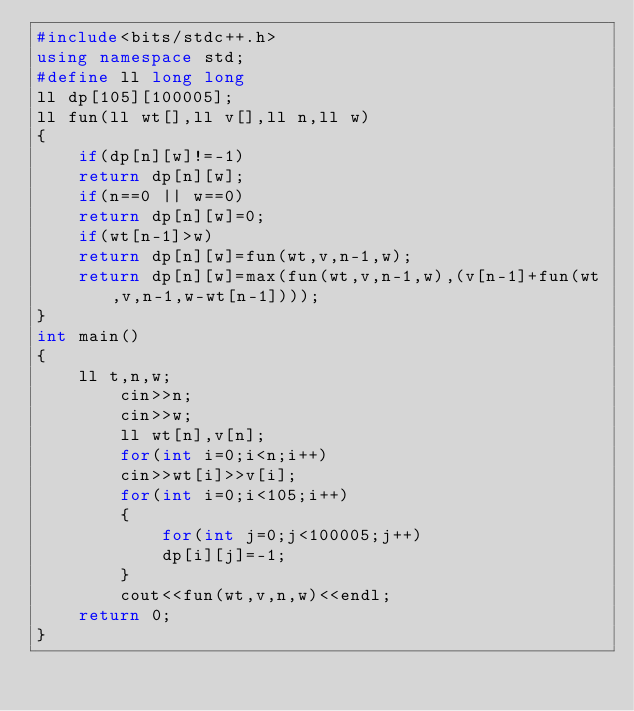<code> <loc_0><loc_0><loc_500><loc_500><_C++_>#include<bits/stdc++.h>
using namespace std;
#define ll long long 
ll dp[105][100005];
ll fun(ll wt[],ll v[],ll n,ll w)
{
    if(dp[n][w]!=-1)
    return dp[n][w];
    if(n==0 || w==0)
    return dp[n][w]=0;
    if(wt[n-1]>w)
    return dp[n][w]=fun(wt,v,n-1,w);
    return dp[n][w]=max(fun(wt,v,n-1,w),(v[n-1]+fun(wt,v,n-1,w-wt[n-1])));
}
int main()
{
    ll t,n,w;
        cin>>n;
        cin>>w;
        ll wt[n],v[n];
        for(int i=0;i<n;i++)
        cin>>wt[i]>>v[i];
        for(int i=0;i<105;i++)
        {
            for(int j=0;j<100005;j++)
            dp[i][j]=-1;
        }
        cout<<fun(wt,v,n,w)<<endl;
    return 0;
}
</code> 